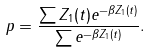Convert formula to latex. <formula><loc_0><loc_0><loc_500><loc_500>p = \frac { \sum Z _ { 1 } ( t ) e ^ { - \beta Z _ { 1 } ( t ) } } { \sum e ^ { - \beta Z _ { 1 } ( t ) } } .</formula> 